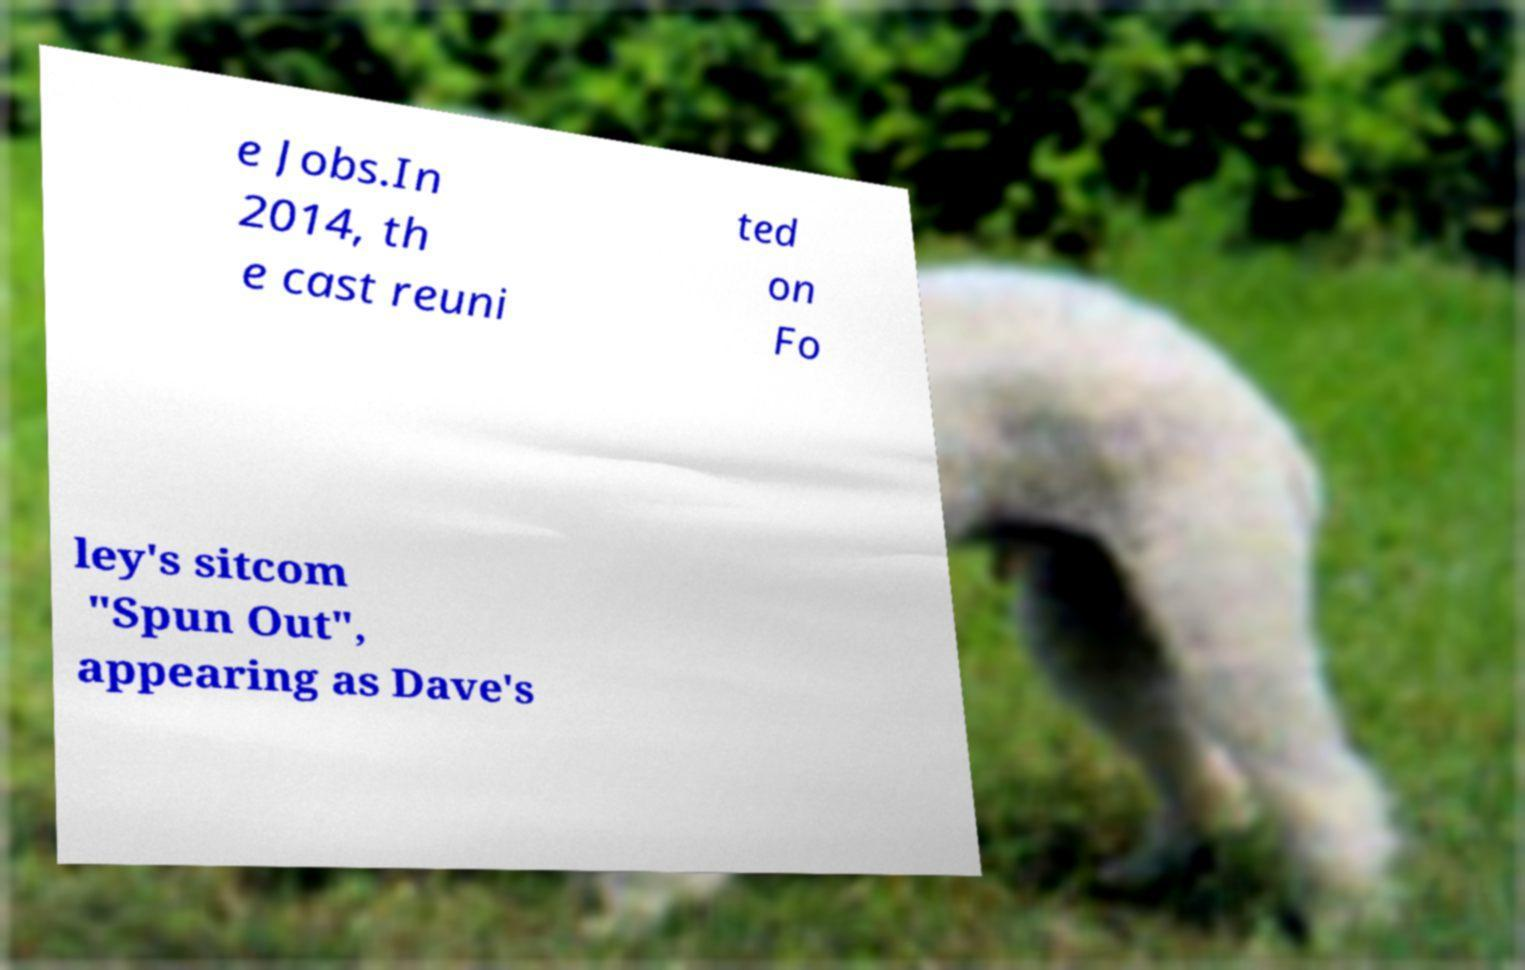For documentation purposes, I need the text within this image transcribed. Could you provide that? e Jobs.In 2014, th e cast reuni ted on Fo ley's sitcom "Spun Out", appearing as Dave's 